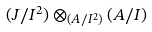<formula> <loc_0><loc_0><loc_500><loc_500>( J / I ^ { 2 } ) \otimes _ { ( A / I ^ { 2 } ) } ( A / I )</formula> 